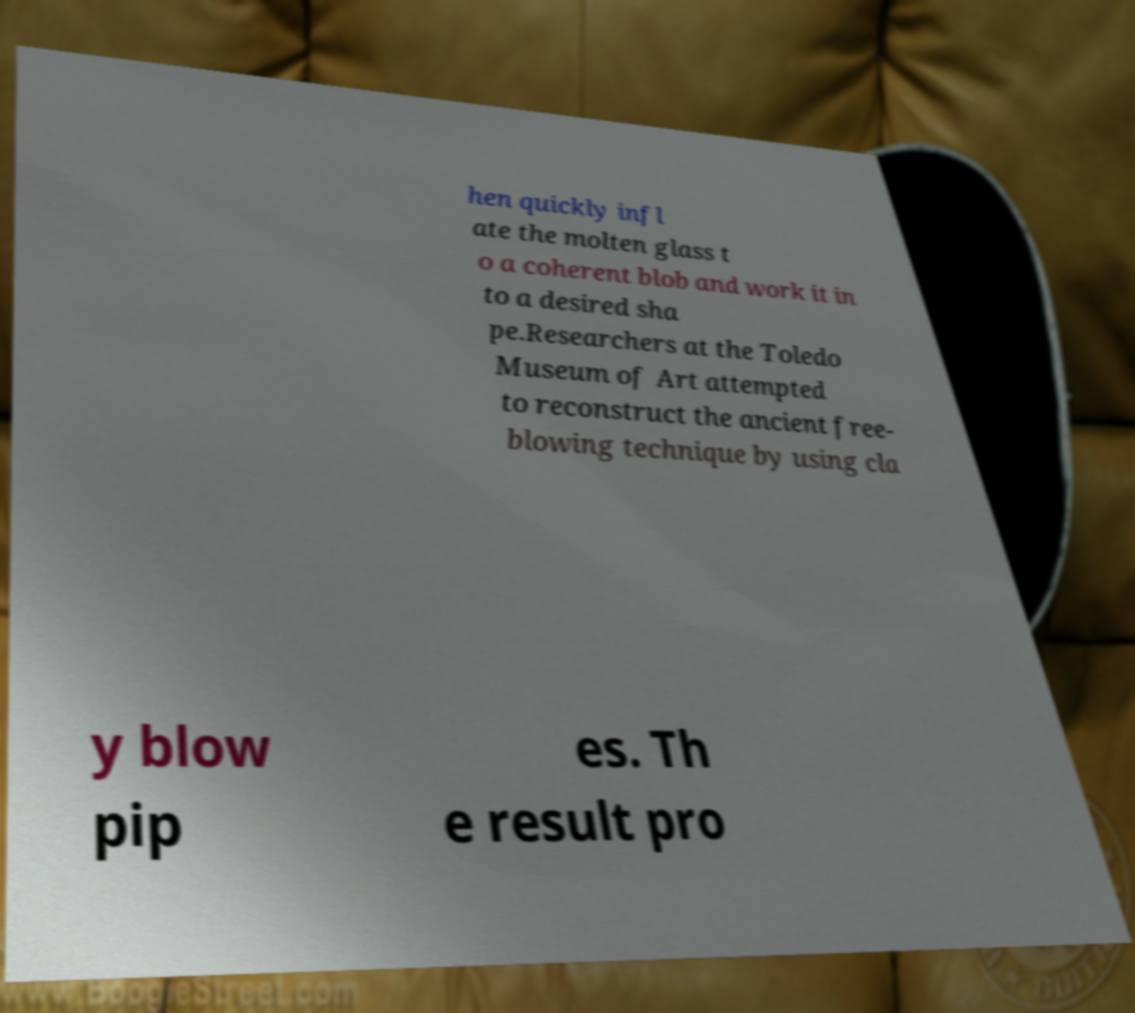Could you extract and type out the text from this image? hen quickly infl ate the molten glass t o a coherent blob and work it in to a desired sha pe.Researchers at the Toledo Museum of Art attempted to reconstruct the ancient free- blowing technique by using cla y blow pip es. Th e result pro 